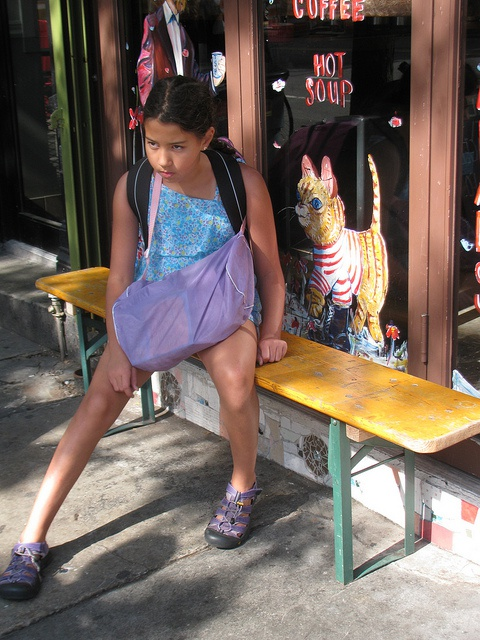Describe the objects in this image and their specific colors. I can see people in black, brown, and gray tones, bench in black, white, orange, gold, and gray tones, handbag in black, gray, and violet tones, and backpack in black, gray, and maroon tones in this image. 